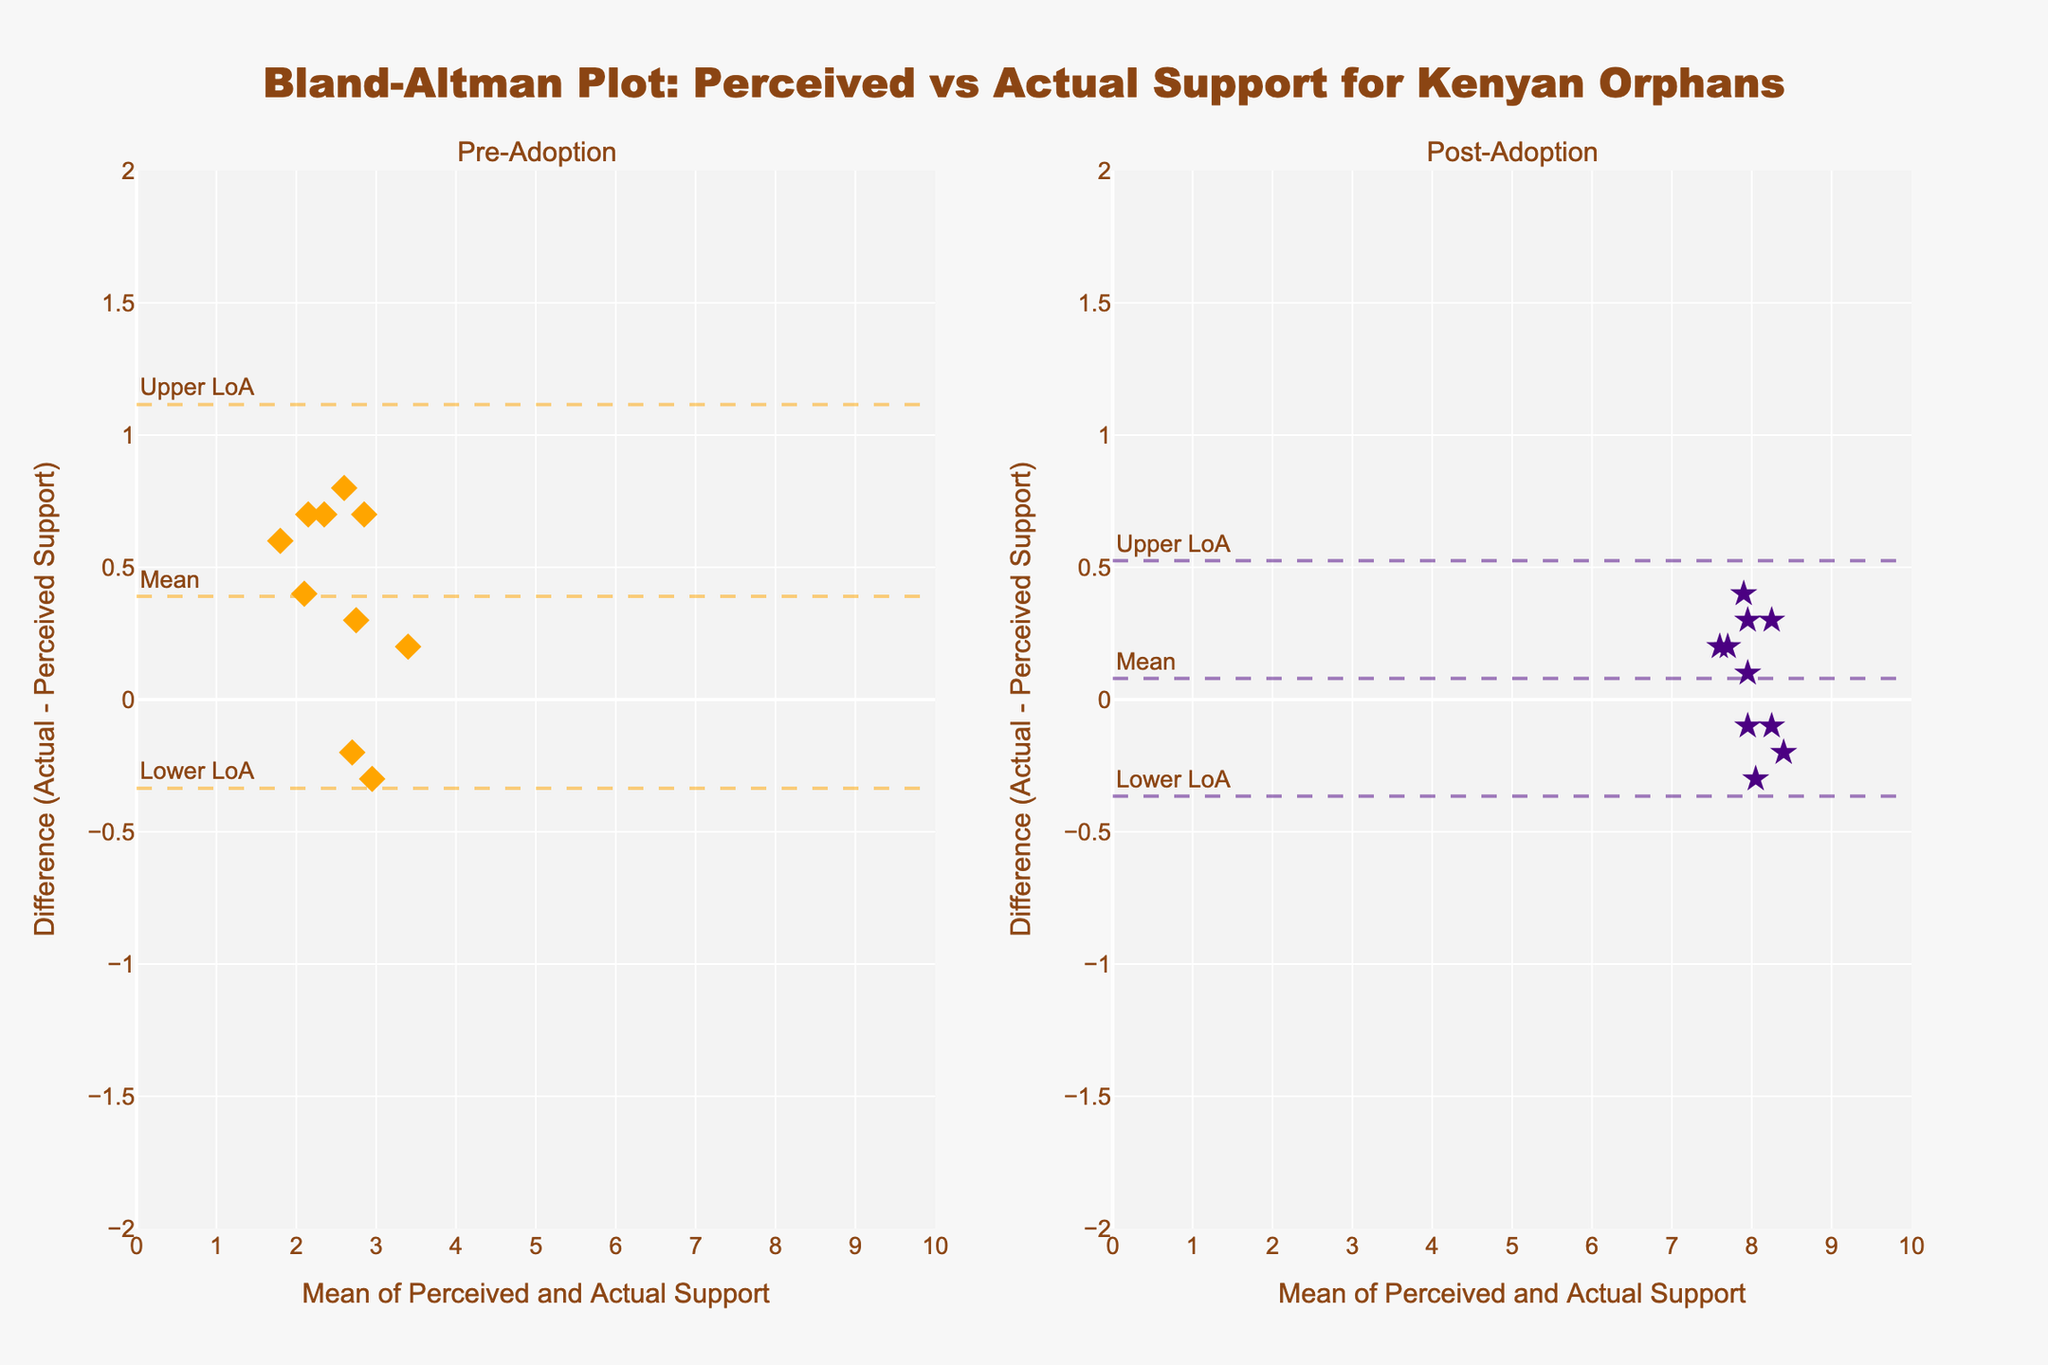What is the title of the plot? The title is prominently displayed at the top center of the figure. You can read the title directly from the figure.
Answer: Bland-Altman Plot: Perceived vs Actual Support for Kenyan Orphans How many subplots are there, and what does each subplot represent? The figure is divided into two subplots, which are titled "Pre-Adoption" and "Post-Adoption." These titles are located at the top of each subplot.
Answer: 2 subplots, Pre-Adoption and Post-Adoption What is the color used to represent data points for pre-adoption and post-adoption? The pre-adoption data points are in orange, while the post-adoption data points are in purple. This can be identified by looking at the color of the markers in each subplot.
Answer: Orange and Purple What do the horizontal dashed lines in each subplot indicate? The horizontal dashed lines in each subplot represent the mean bias, upper limit of agreement (LoA), and lower LoA. These are labeled with "Mean," "Upper LoA," and "Lower LoA."
Answer: Mean, Upper LoA, Lower LoA What is the range used for the y-axis, and what does it represent? The y-axis ranges from -2 to 2, and it represents the difference between actual support and perceived support (Actual - Perceived Support). This range can be identified by looking at the ticks and labels on the y-axis of each subplot.
Answer: -2 to 2 What is the mean bias for pre-adoption? To find this, look at the horizontal dashed line labeled "Mean" in the pre-adoption subplot. The y-value of this line represents the mean bias.
Answer: Approximately 0.24 What is the mean bias for post-adoption? To find this, look at the horizontal dashed line labeled "Mean" in the post-adoption subplot. The y-value of this line represents the mean bias.
Answer: Approximately -0.02 Compare the mean biases of pre-adoption and post-adoption. Which is higher? By examining the y-values of the "Mean" dashed lines in both subplots, we can compare their heights. The pre-adoption mean bias is around 0.24 while the post-adoption mean bias is around -0.02.
Answer: Pre-adoption Are the differences between actual and perceived support larger before or after adoption? Compare the spread and range of the data points around the mean bias lines in both subplots. The data points are more spread out in the pre-adoption subplot, indicating larger differences before adoption.
Answer: Before adoption Which subplot shows greater consistency between actual and perceived support levels? Consistency can be inferred from the closeness of data points to the mean bias line. The post-adoption subplot shows data points closer to the mean bias line, indicating greater consistency.
Answer: Post-adoption 